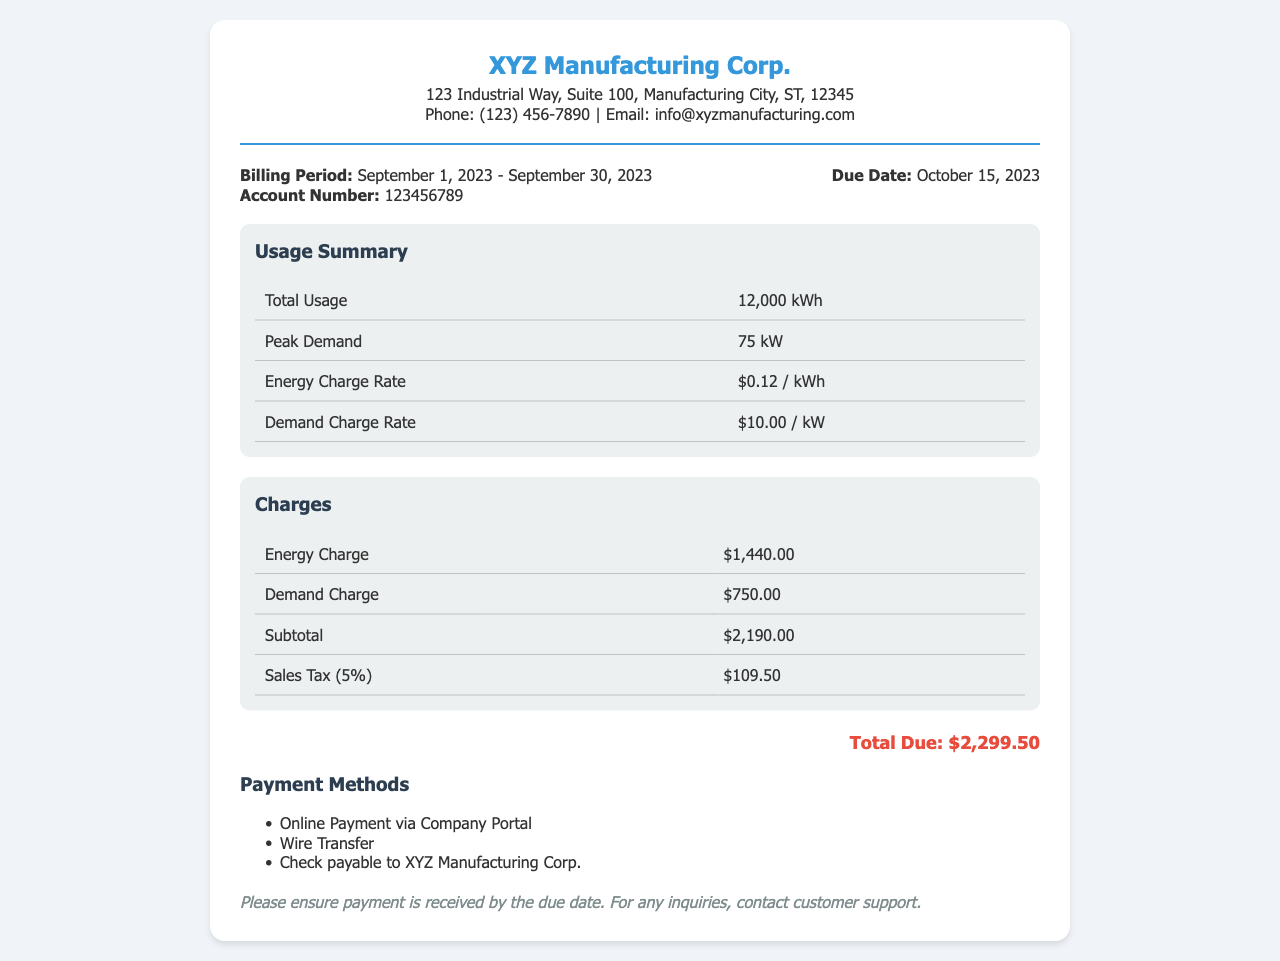What is the billing period? The billing period is specified in the document between "Billing Period:" and the dates provided.
Answer: September 1, 2023 - September 30, 2023 What is the account number? The account number is given under "Account Number:" in the billing information section.
Answer: 123456789 What is the total usage of electricity? The total usage is stated in the usage summary as "Total Usage" with its corresponding value.
Answer: 12,000 kWh What is the peak demand? The peak demand is provided in the usage summary as "Peak Demand."
Answer: 75 kW What is the demand charge rate? The demand charge rate is mentioned in the usage summary under "Demand Charge Rate."
Answer: $10.00 / kW What is the subtotal of the charges? The subtotal can be found under the charges section labeled as "Subtotal."
Answer: $2,190.00 How much is the sales tax? The sales tax amount is indicated in the charges table under "Sales Tax (5%)."
Answer: $109.50 What is the total due amount? The total due is clearly presented at the bottom of the document labeled as "Total Due."
Answer: $2,299.50 What are the available payment methods? The payment methods are listed under the "Payment Methods" section.
Answer: Online Payment, Wire Transfer, Check 